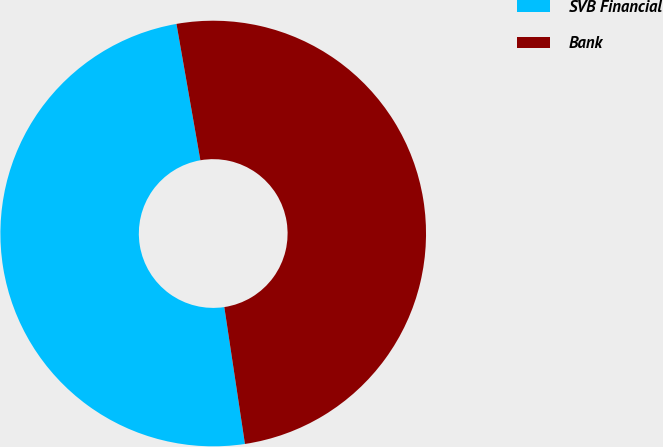<chart> <loc_0><loc_0><loc_500><loc_500><pie_chart><fcel>SVB Financial<fcel>Bank<nl><fcel>49.62%<fcel>50.38%<nl></chart> 